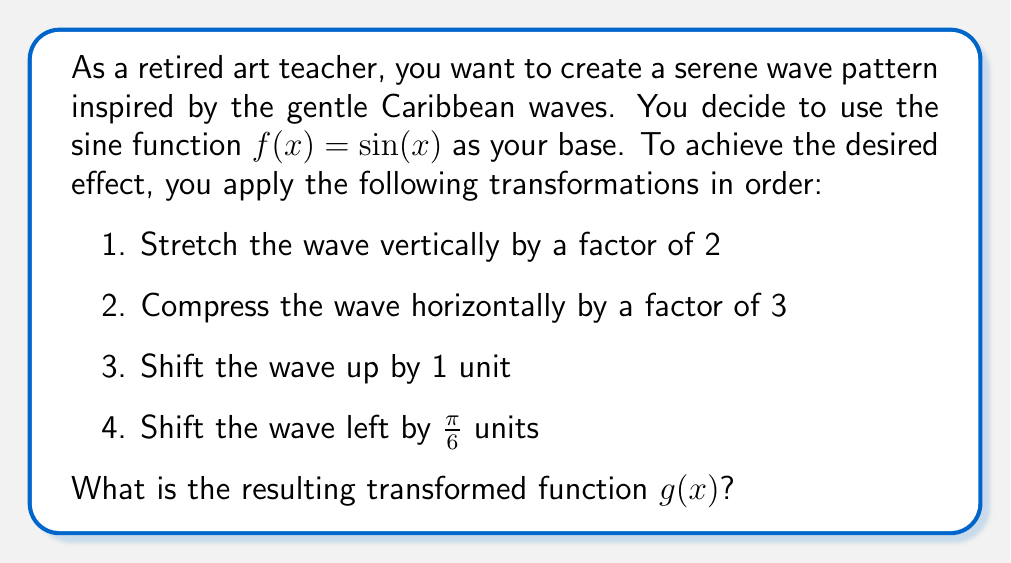Can you answer this question? Let's apply the transformations step by step:

1. Stretch vertically by a factor of 2:
   $f_1(x) = 2\sin(x)$

2. Compress horizontally by a factor of 3:
   $f_2(x) = 2\sin(3x)$

3. Shift up by 1 unit:
   $f_3(x) = 2\sin(3x) + 1$

4. Shift left by $\frac{\pi}{6}$ units:
   To shift left, we add the value inside the parentheses.
   $g(x) = 2\sin(3(x + \frac{\pi}{6})) + 1$

   Simplify the expression inside the parentheses:
   $g(x) = 2\sin(3x + \frac{\pi}{2}) + 1$

Therefore, the final transformed function is $g(x) = 2\sin(3x + \frac{\pi}{2}) + 1$.
Answer: $g(x) = 2\sin(3x + \frac{\pi}{2}) + 1$ 